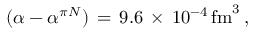<formula> <loc_0><loc_0><loc_500><loc_500>( \alpha - \alpha ^ { \pi N } ) \, = \, 9 . 6 \, \times \, 1 0 ^ { - 4 } \, f m ^ { 3 } \, ,</formula> 